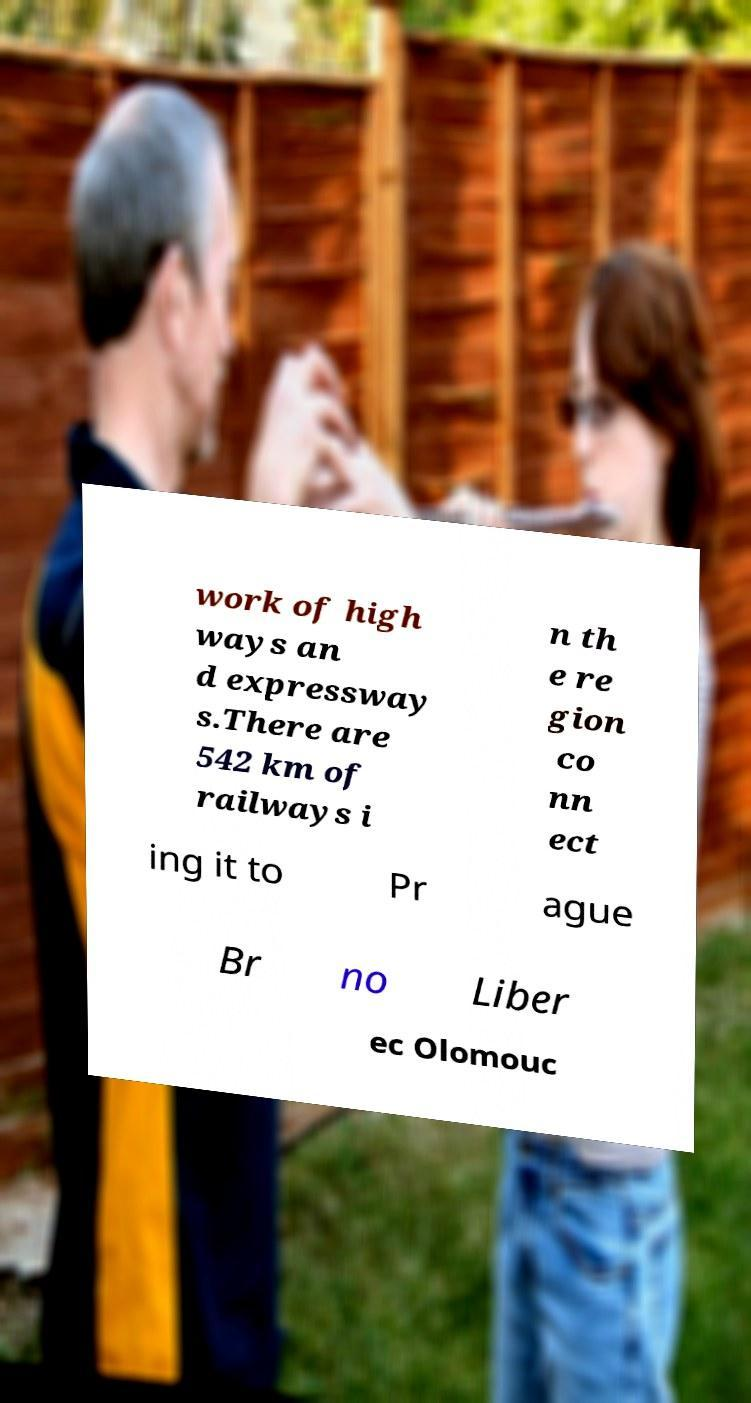Could you extract and type out the text from this image? work of high ways an d expressway s.There are 542 km of railways i n th e re gion co nn ect ing it to Pr ague Br no Liber ec Olomouc 